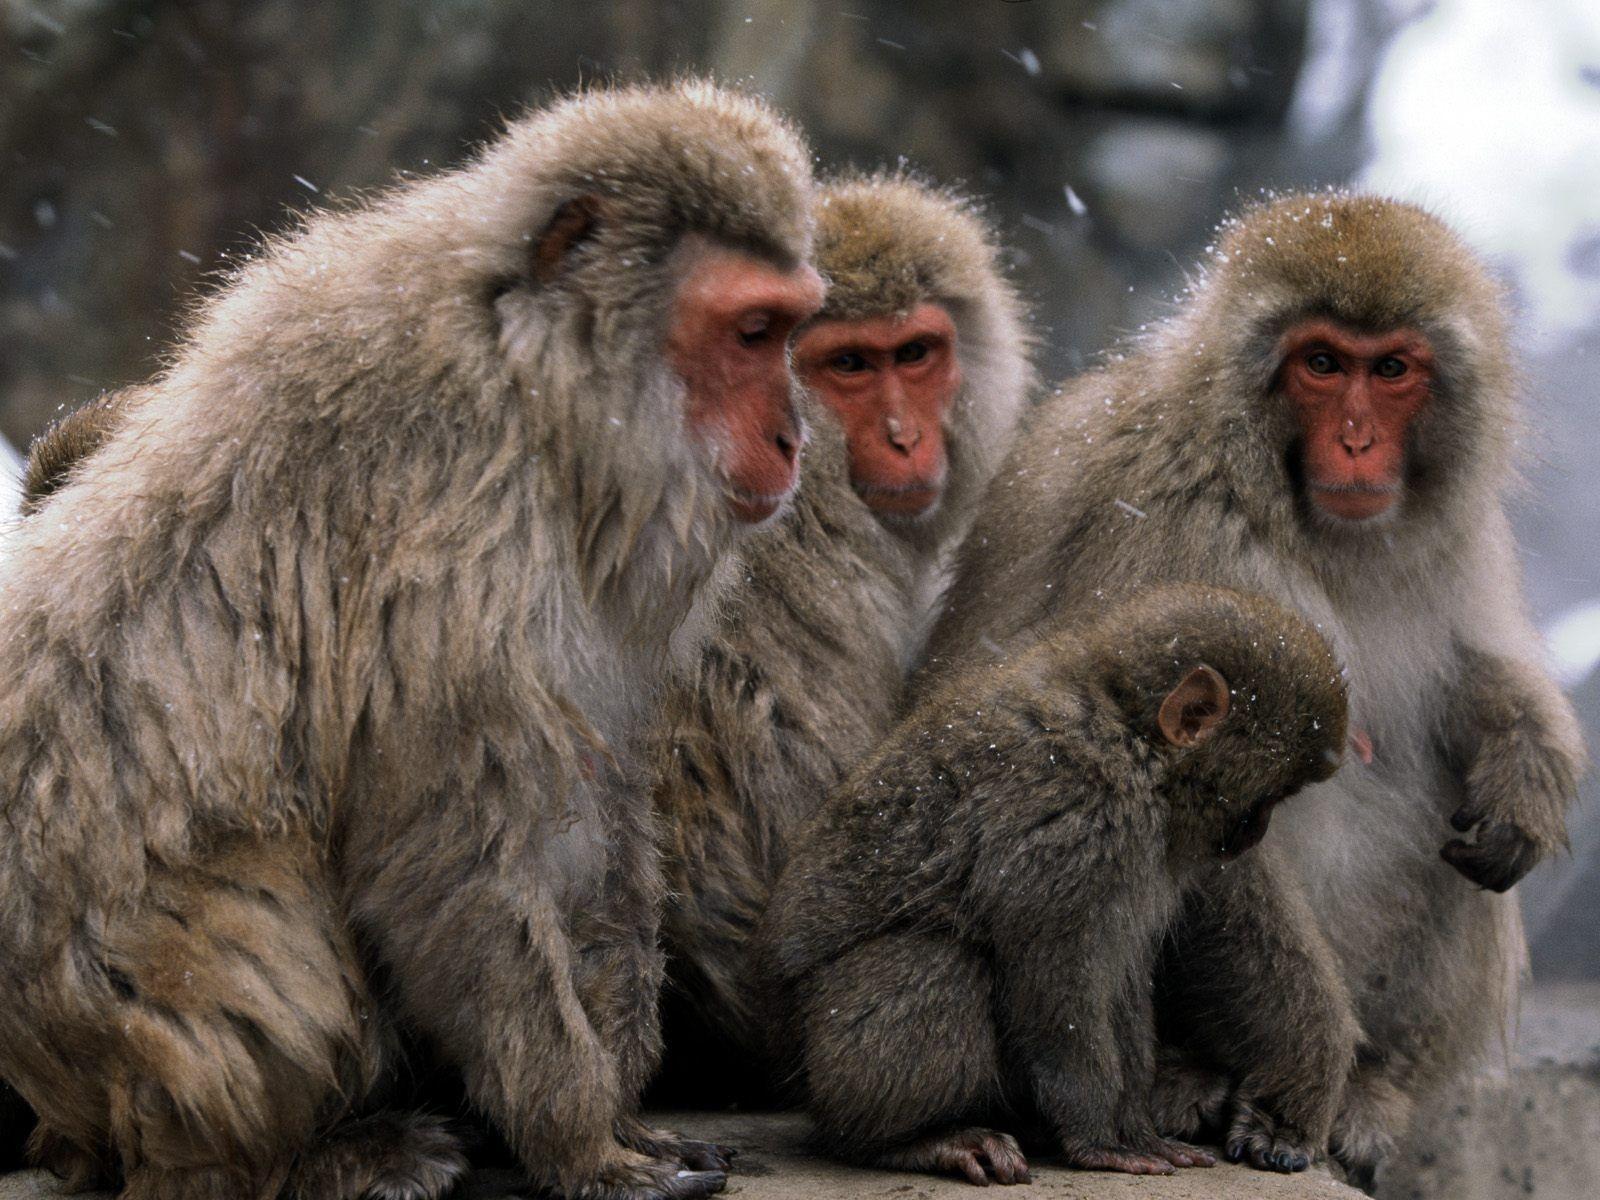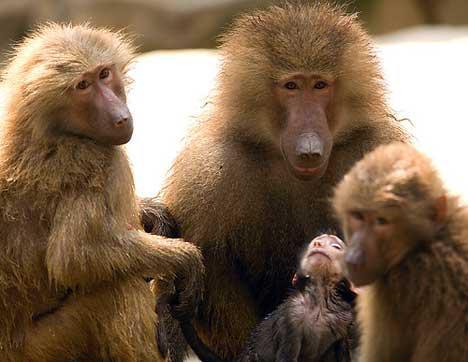The first image is the image on the left, the second image is the image on the right. Analyze the images presented: Is the assertion "There are more than seven monkeys in the image on the right." valid? Answer yes or no. No. The first image is the image on the left, the second image is the image on the right. Evaluate the accuracy of this statement regarding the images: "An image shows at least 10 monkeys on a green field.". Is it true? Answer yes or no. No. 